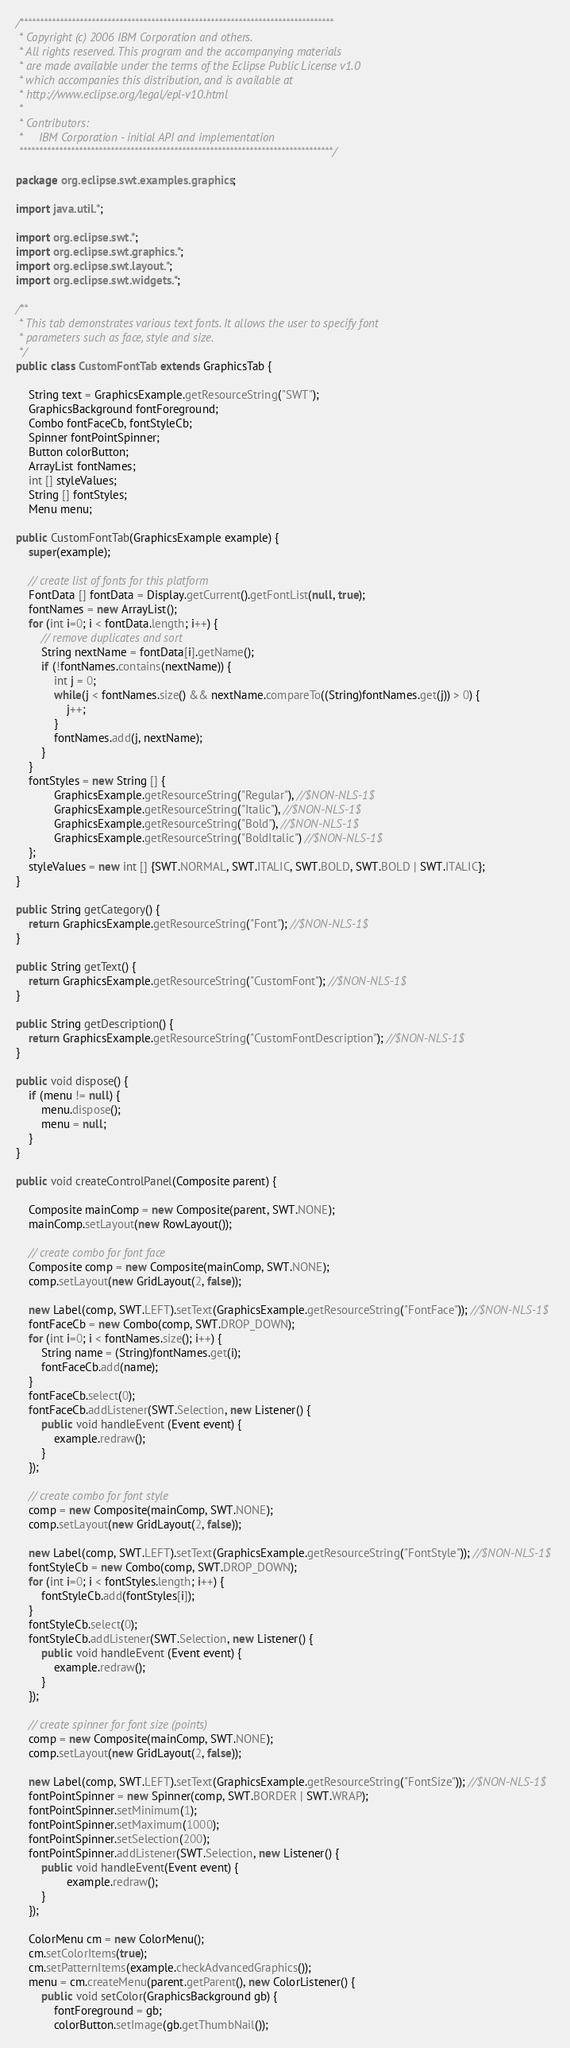Convert code to text. <code><loc_0><loc_0><loc_500><loc_500><_Java_>/*******************************************************************************
 * Copyright (c) 2006 IBM Corporation and others.
 * All rights reserved. This program and the accompanying materials
 * are made available under the terms of the Eclipse Public License v1.0
 * which accompanies this distribution, and is available at
 * http://www.eclipse.org/legal/epl-v10.html
 *
 * Contributors:
 *     IBM Corporation - initial API and implementation
 *******************************************************************************/

package org.eclipse.swt.examples.graphics;

import java.util.*;

import org.eclipse.swt.*;
import org.eclipse.swt.graphics.*;
import org.eclipse.swt.layout.*;
import org.eclipse.swt.widgets.*;

/**
 * This tab demonstrates various text fonts. It allows the user to specify font
 * parameters such as face, style and size.
 */
public class CustomFontTab extends GraphicsTab {

	String text = GraphicsExample.getResourceString("SWT");
	GraphicsBackground fontForeground;
	Combo fontFaceCb, fontStyleCb;
	Spinner fontPointSpinner;
	Button colorButton;
	ArrayList fontNames;
	int [] styleValues;
	String [] fontStyles;
	Menu menu;
	
public CustomFontTab(GraphicsExample example) {
	super(example);
	
	// create list of fonts for this platform
	FontData [] fontData = Display.getCurrent().getFontList(null, true);
	fontNames = new ArrayList();
	for (int i=0; i < fontData.length; i++) {
		// remove duplicates and sort
		String nextName = fontData[i].getName();
		if (!fontNames.contains(nextName)) {
			int j = 0;
			while(j < fontNames.size() && nextName.compareTo((String)fontNames.get(j)) > 0) {
				j++;
			}
			fontNames.add(j, nextName);
		}
	}
	fontStyles = new String [] {
			GraphicsExample.getResourceString("Regular"), //$NON-NLS-1$
			GraphicsExample.getResourceString("Italic"), //$NON-NLS-1$
			GraphicsExample.getResourceString("Bold"), //$NON-NLS-1$
			GraphicsExample.getResourceString("BoldItalic") //$NON-NLS-1$
	};
	styleValues = new int [] {SWT.NORMAL, SWT.ITALIC, SWT.BOLD, SWT.BOLD | SWT.ITALIC};
}

public String getCategory() {
	return GraphicsExample.getResourceString("Font"); //$NON-NLS-1$
}

public String getText() {
	return GraphicsExample.getResourceString("CustomFont"); //$NON-NLS-1$
}

public String getDescription() {
	return GraphicsExample.getResourceString("CustomFontDescription"); //$NON-NLS-1$
}

public void dispose() {
	if (menu != null) {
		menu.dispose();
		menu = null;
	}
}

public void createControlPanel(Composite parent) {

	Composite mainComp = new Composite(parent, SWT.NONE);
	mainComp.setLayout(new RowLayout());
	
	// create combo for font face
	Composite comp = new Composite(mainComp, SWT.NONE);
	comp.setLayout(new GridLayout(2, false));
	
	new Label(comp, SWT.LEFT).setText(GraphicsExample.getResourceString("FontFace")); //$NON-NLS-1$
	fontFaceCb = new Combo(comp, SWT.DROP_DOWN);
	for (int i=0; i < fontNames.size(); i++) {
		String name = (String)fontNames.get(i);
		fontFaceCb.add(name);
	}
	fontFaceCb.select(0);
	fontFaceCb.addListener(SWT.Selection, new Listener() {
		public void handleEvent (Event event) {
			example.redraw();
		}
	});
	
	// create combo for font style
	comp = new Composite(mainComp, SWT.NONE);
	comp.setLayout(new GridLayout(2, false));
	
	new Label(comp, SWT.LEFT).setText(GraphicsExample.getResourceString("FontStyle")); //$NON-NLS-1$
	fontStyleCb = new Combo(comp, SWT.DROP_DOWN);
	for (int i=0; i < fontStyles.length; i++) {
		fontStyleCb.add(fontStyles[i]);
	}
	fontStyleCb.select(0);
	fontStyleCb.addListener(SWT.Selection, new Listener() {
		public void handleEvent (Event event) {
			example.redraw();
		}
	});
	
	// create spinner for font size (points)
	comp = new Composite(mainComp, SWT.NONE);
	comp.setLayout(new GridLayout(2, false));
	
	new Label(comp, SWT.LEFT).setText(GraphicsExample.getResourceString("FontSize")); //$NON-NLS-1$
	fontPointSpinner = new Spinner(comp, SWT.BORDER | SWT.WRAP);
	fontPointSpinner.setMinimum(1);
	fontPointSpinner.setMaximum(1000);
	fontPointSpinner.setSelection(200);
	fontPointSpinner.addListener(SWT.Selection, new Listener() {
		public void handleEvent(Event event) {
				example.redraw();
		}
	});

	ColorMenu cm = new ColorMenu();
	cm.setColorItems(true);
	cm.setPatternItems(example.checkAdvancedGraphics());
	menu = cm.createMenu(parent.getParent(), new ColorListener() {
		public void setColor(GraphicsBackground gb) {
			fontForeground = gb;
			colorButton.setImage(gb.getThumbNail());</code> 